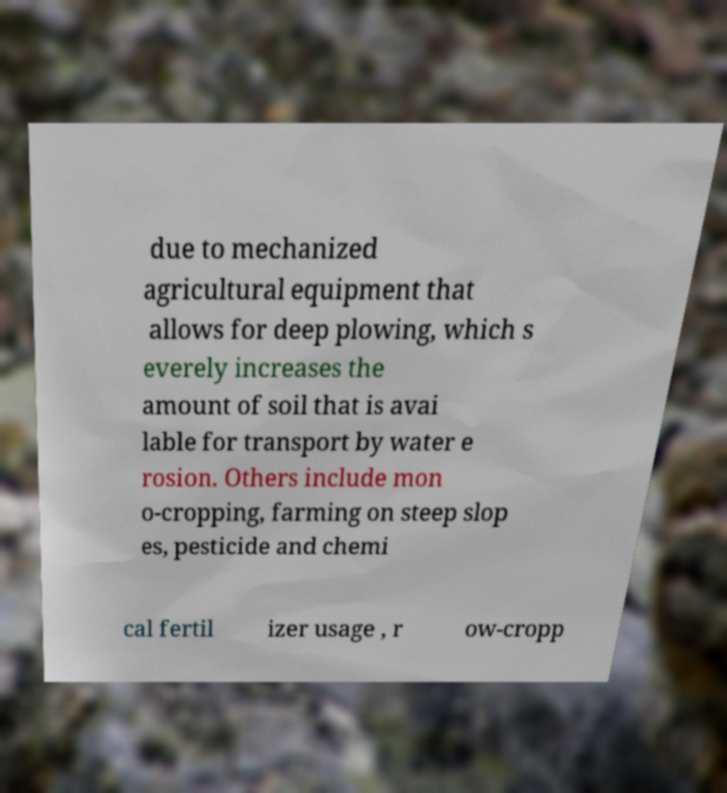I need the written content from this picture converted into text. Can you do that? due to mechanized agricultural equipment that allows for deep plowing, which s everely increases the amount of soil that is avai lable for transport by water e rosion. Others include mon o-cropping, farming on steep slop es, pesticide and chemi cal fertil izer usage , r ow-cropp 